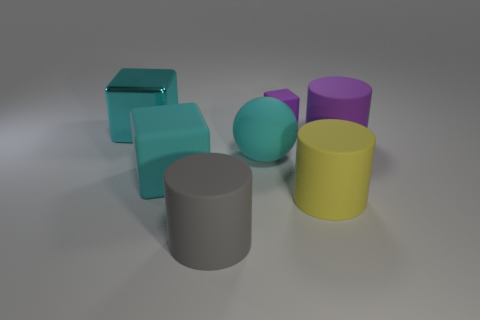Is there anything else that has the same size as the purple cylinder?
Offer a terse response. Yes. Are there any cyan metallic blocks to the right of the big matte cube?
Make the answer very short. No. Do the large cylinder that is left of the small purple matte cube and the matte block on the left side of the gray thing have the same color?
Your response must be concise. No. Is there a yellow matte thing of the same shape as the gray object?
Your answer should be compact. Yes. How many other objects are there of the same color as the metallic block?
Provide a succinct answer. 2. There is a matte block that is behind the large cyan matte object on the left side of the large cylinder that is to the left of the cyan matte sphere; what is its color?
Make the answer very short. Purple. Are there an equal number of big cyan things on the right side of the large purple object and small red rubber balls?
Offer a very short reply. Yes. Do the cyan matte object that is on the right side of the gray matte object and the big yellow cylinder have the same size?
Your answer should be compact. Yes. What number of large yellow things are there?
Ensure brevity in your answer.  1. What number of big rubber cylinders are both left of the yellow rubber cylinder and on the right side of the big yellow thing?
Your answer should be very brief. 0. 